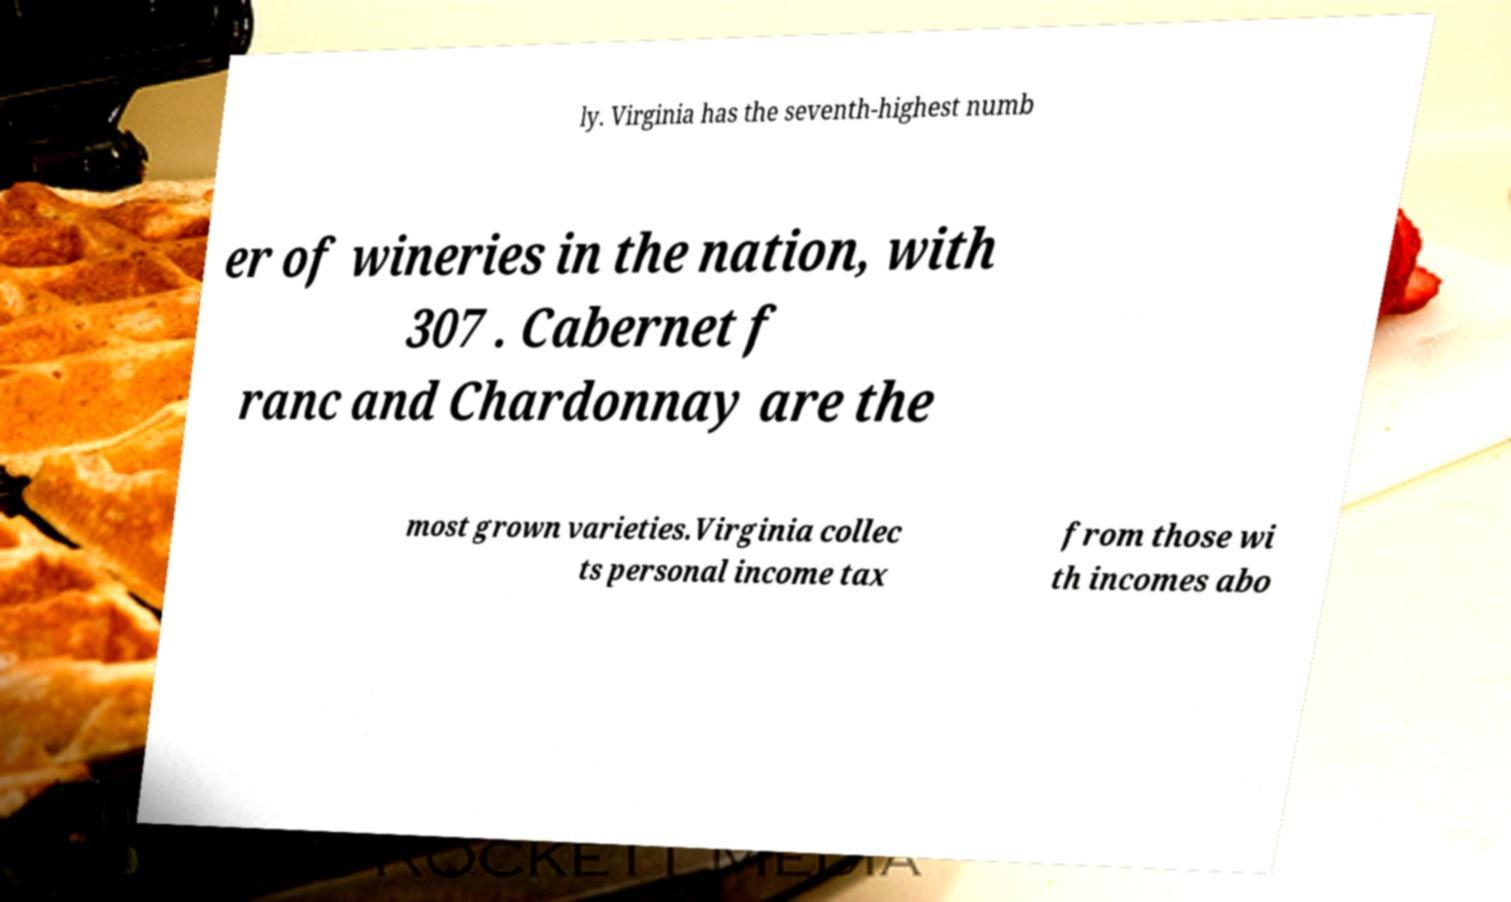Can you accurately transcribe the text from the provided image for me? ly. Virginia has the seventh-highest numb er of wineries in the nation, with 307 . Cabernet f ranc and Chardonnay are the most grown varieties.Virginia collec ts personal income tax from those wi th incomes abo 